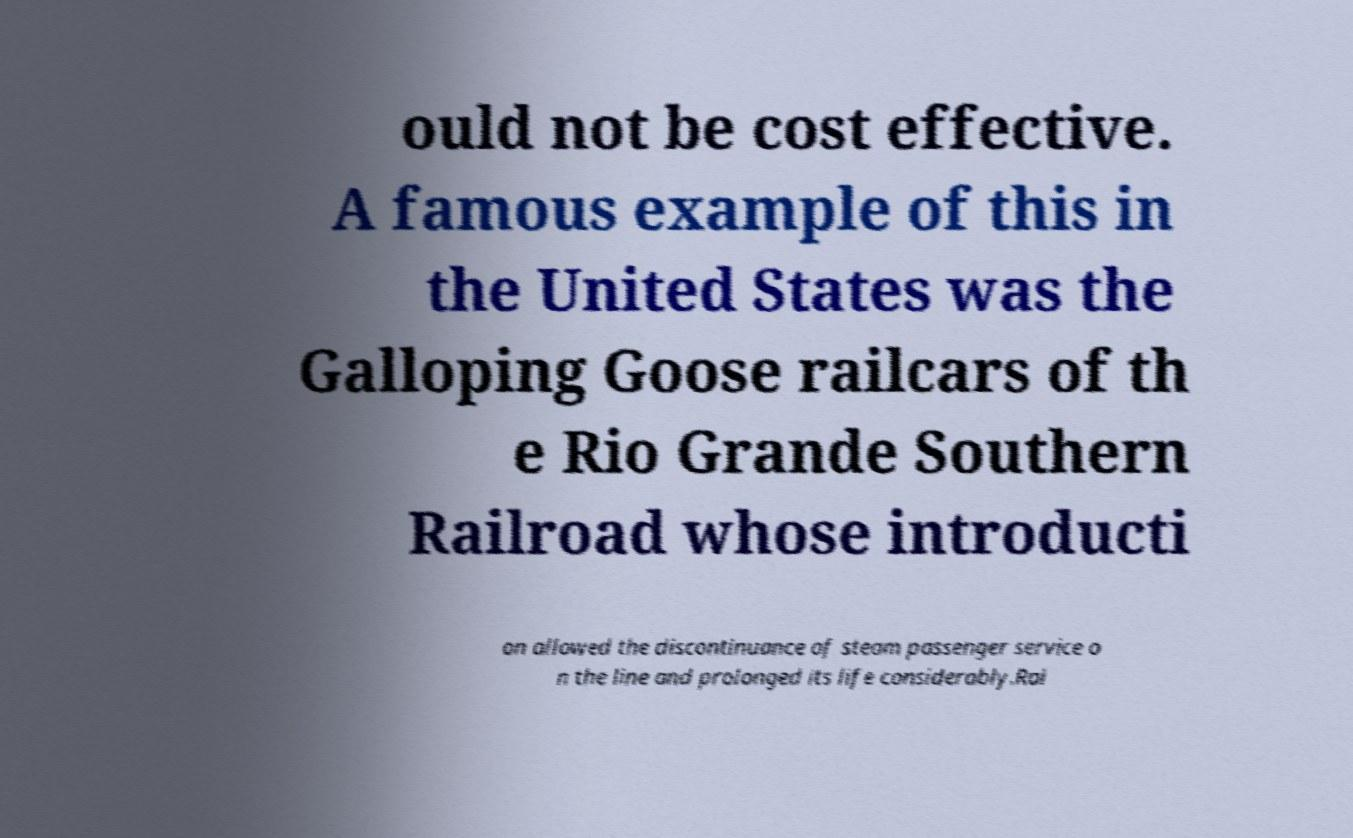Could you extract and type out the text from this image? ould not be cost effective. A famous example of this in the United States was the Galloping Goose railcars of th e Rio Grande Southern Railroad whose introducti on allowed the discontinuance of steam passenger service o n the line and prolonged its life considerably.Rai 